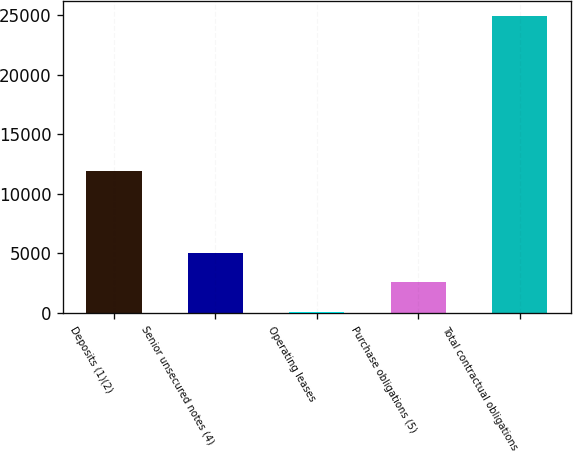Convert chart. <chart><loc_0><loc_0><loc_500><loc_500><bar_chart><fcel>Deposits (1)(2)<fcel>Senior unsecured notes (4)<fcel>Operating leases<fcel>Purchase obligations (5)<fcel>Total contractual obligations<nl><fcel>11943<fcel>5049.8<fcel>81<fcel>2565.4<fcel>24925<nl></chart> 